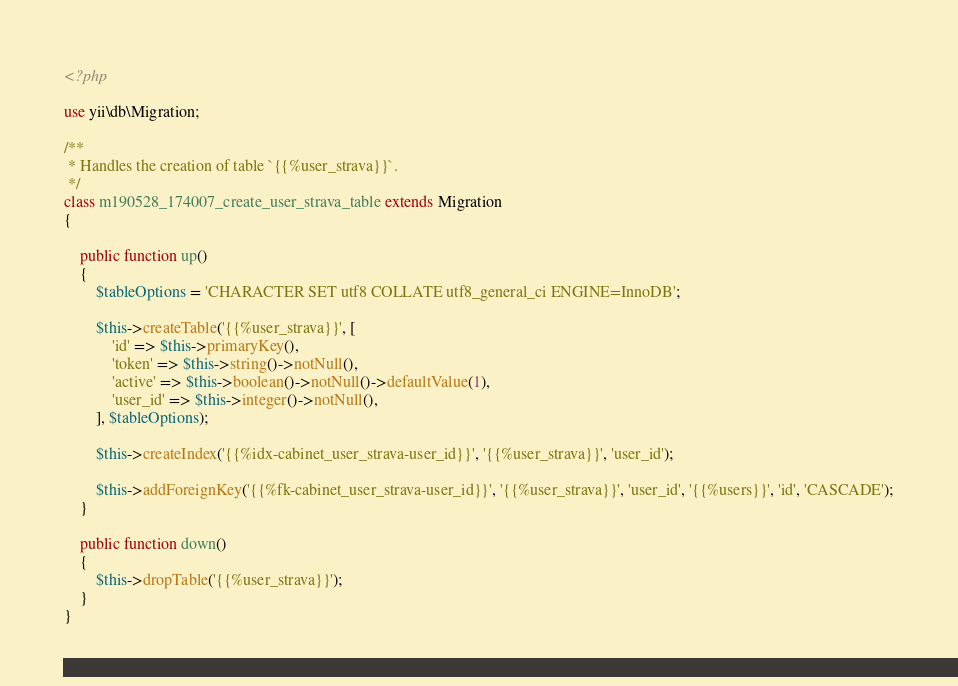<code> <loc_0><loc_0><loc_500><loc_500><_PHP_><?php

use yii\db\Migration;

/**
 * Handles the creation of table `{{%user_strava}}`.
 */
class m190528_174007_create_user_strava_table extends Migration
{

    public function up()
    {
        $tableOptions = 'CHARACTER SET utf8 COLLATE utf8_general_ci ENGINE=InnoDB';

        $this->createTable('{{%user_strava}}', [
            'id' => $this->primaryKey(),
            'token' => $this->string()->notNull(),
            'active' => $this->boolean()->notNull()->defaultValue(1),
            'user_id' => $this->integer()->notNull(),
        ], $tableOptions);

        $this->createIndex('{{%idx-cabinet_user_strava-user_id}}', '{{%user_strava}}', 'user_id');

        $this->addForeignKey('{{%fk-cabinet_user_strava-user_id}}', '{{%user_strava}}', 'user_id', '{{%users}}', 'id', 'CASCADE');
    }

    public function down()
    {
        $this->dropTable('{{%user_strava}}');
    }
}
</code> 